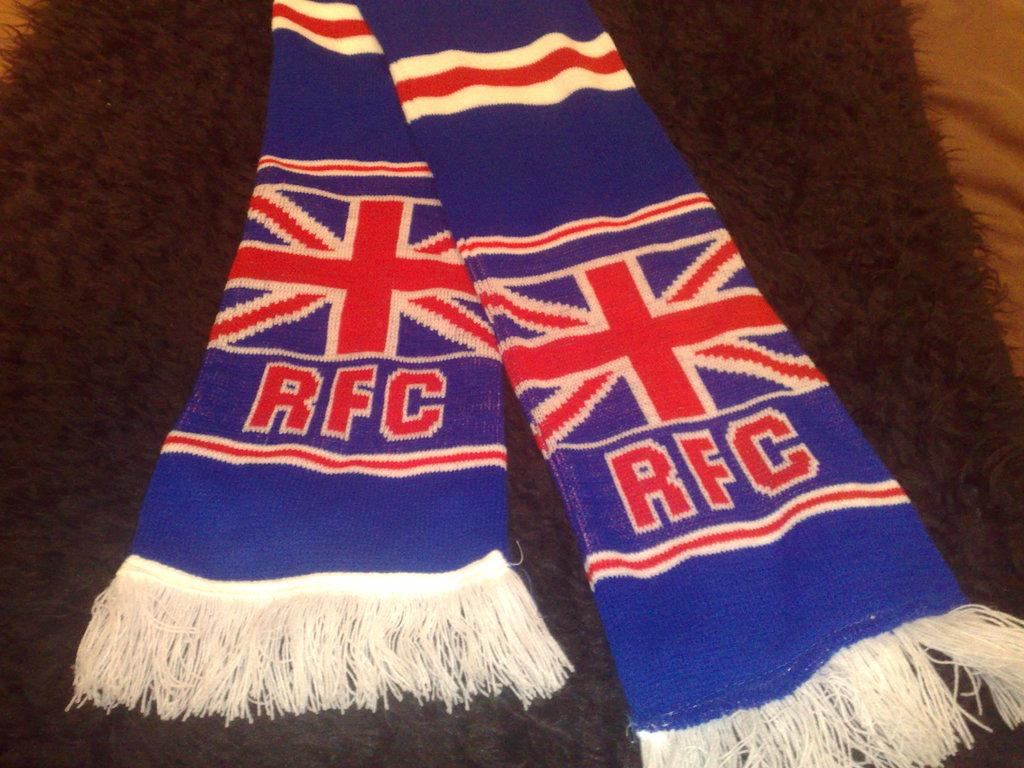Provide a one-sentence caption for the provided image. A blue RFC scarf sitting on a darkly colored carpet. 